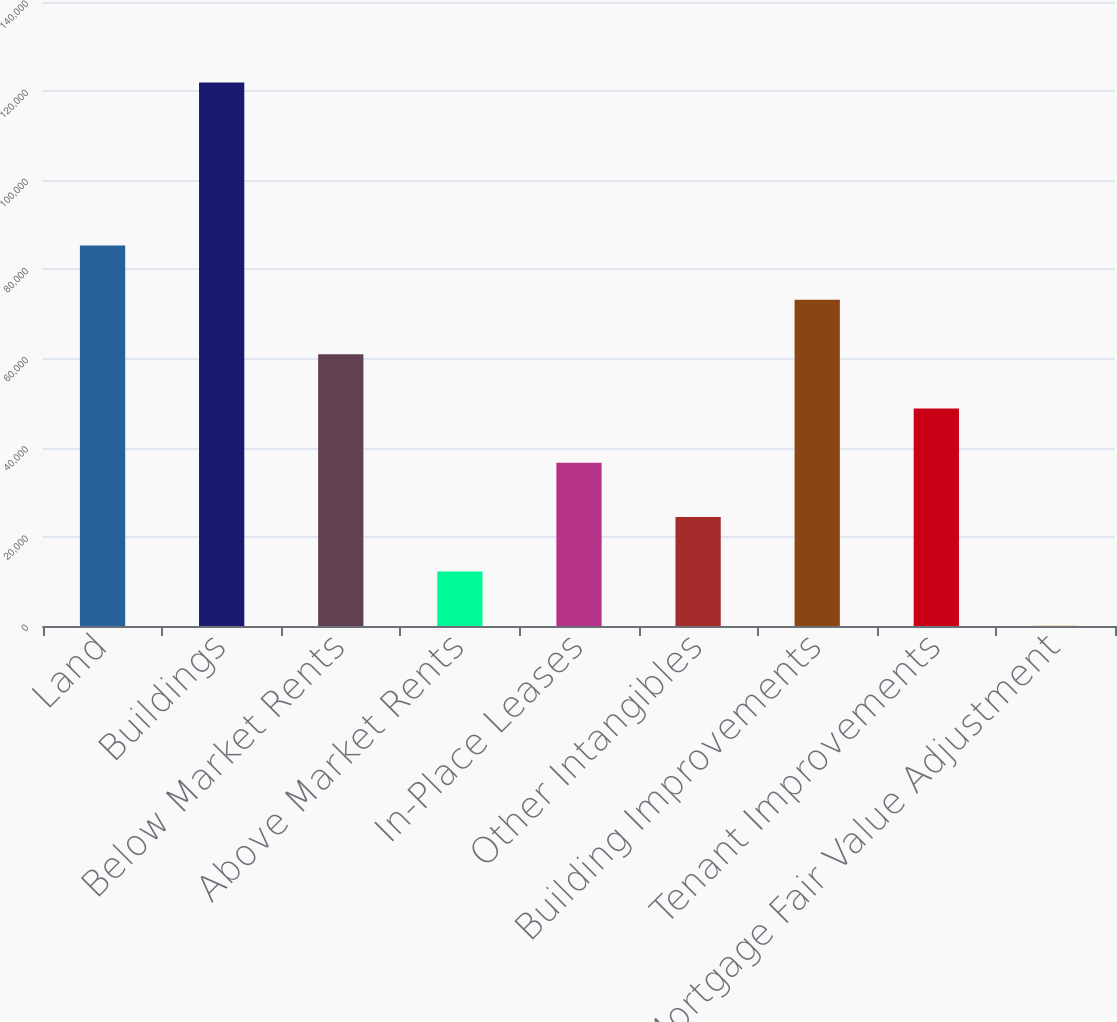Convert chart to OTSL. <chart><loc_0><loc_0><loc_500><loc_500><bar_chart><fcel>Land<fcel>Buildings<fcel>Below Market Rents<fcel>Above Market Rents<fcel>In-Place Leases<fcel>Other Intangibles<fcel>Building Improvements<fcel>Tenant Improvements<fcel>Mortgage Fair Value Adjustment<nl><fcel>85368.4<fcel>121927<fcel>60996<fcel>12251.2<fcel>36623.6<fcel>24437.4<fcel>73182.2<fcel>48809.8<fcel>65<nl></chart> 